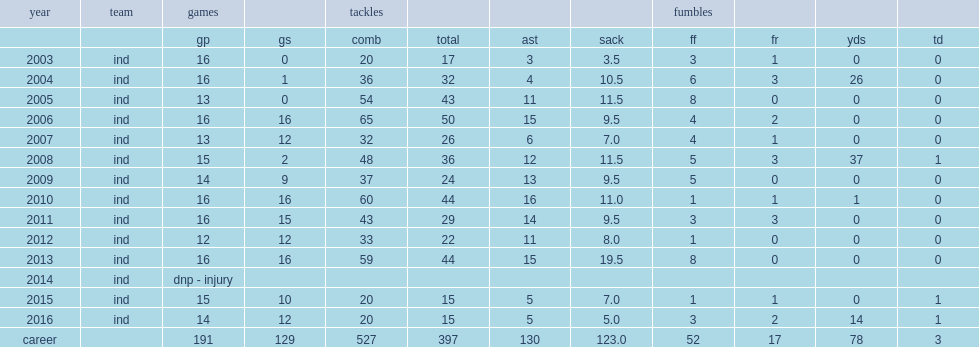In which season did robert mathis finish it with 54 tackles, 11.5 sacks and 8 forced fumbles? 3. 